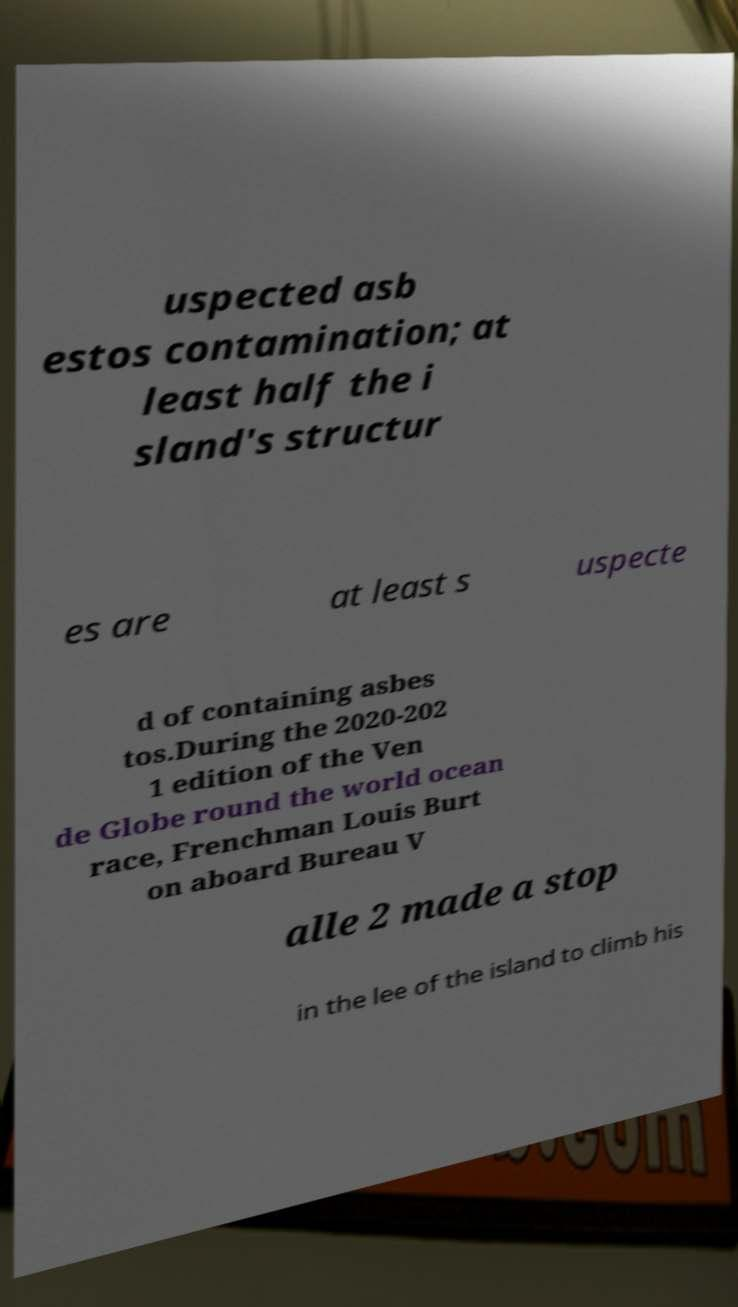What messages or text are displayed in this image? I need them in a readable, typed format. uspected asb estos contamination; at least half the i sland's structur es are at least s uspecte d of containing asbes tos.During the 2020-202 1 edition of the Ven de Globe round the world ocean race, Frenchman Louis Burt on aboard Bureau V alle 2 made a stop in the lee of the island to climb his 